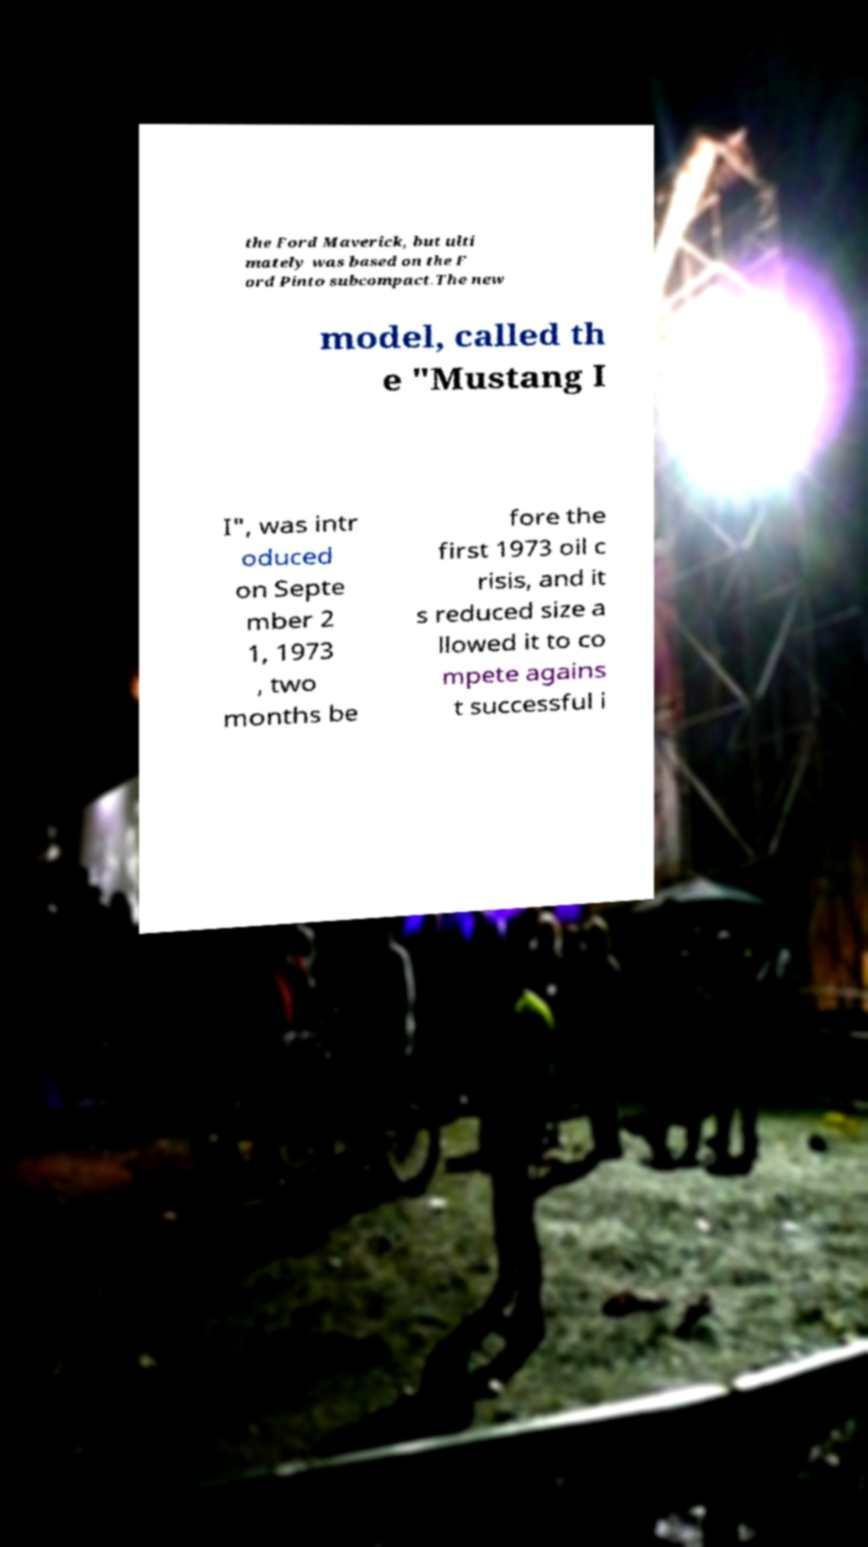There's text embedded in this image that I need extracted. Can you transcribe it verbatim? the Ford Maverick, but ulti mately was based on the F ord Pinto subcompact.The new model, called th e "Mustang I I", was intr oduced on Septe mber 2 1, 1973 , two months be fore the first 1973 oil c risis, and it s reduced size a llowed it to co mpete agains t successful i 